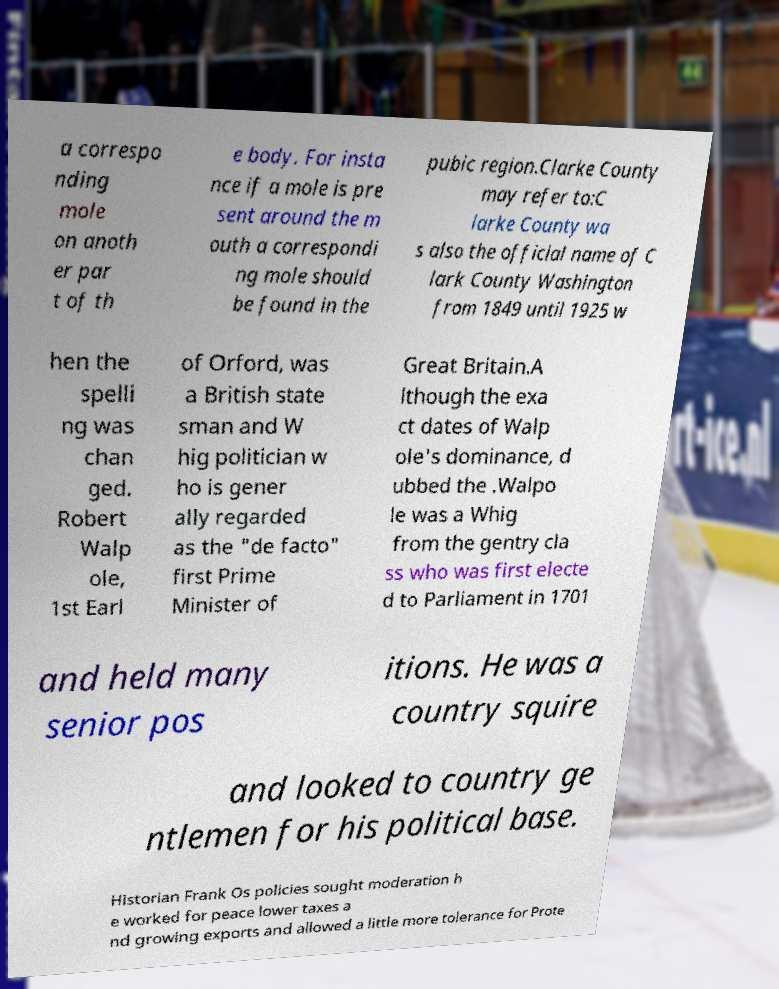Can you accurately transcribe the text from the provided image for me? a correspo nding mole on anoth er par t of th e body. For insta nce if a mole is pre sent around the m outh a correspondi ng mole should be found in the pubic region.Clarke County may refer to:C larke County wa s also the official name of C lark County Washington from 1849 until 1925 w hen the spelli ng was chan ged. Robert Walp ole, 1st Earl of Orford, was a British state sman and W hig politician w ho is gener ally regarded as the "de facto" first Prime Minister of Great Britain.A lthough the exa ct dates of Walp ole's dominance, d ubbed the .Walpo le was a Whig from the gentry cla ss who was first electe d to Parliament in 1701 and held many senior pos itions. He was a country squire and looked to country ge ntlemen for his political base. Historian Frank Os policies sought moderation h e worked for peace lower taxes a nd growing exports and allowed a little more tolerance for Prote 